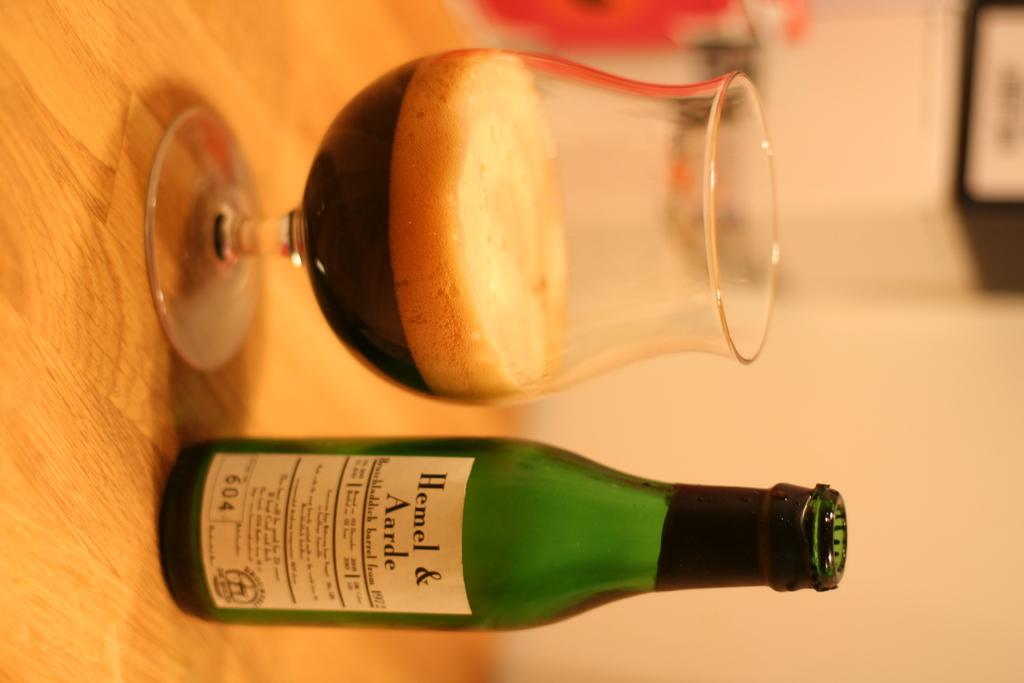<image>
Describe the image concisely. A glass of Hemel & Aarde beer next to a green bottle. 